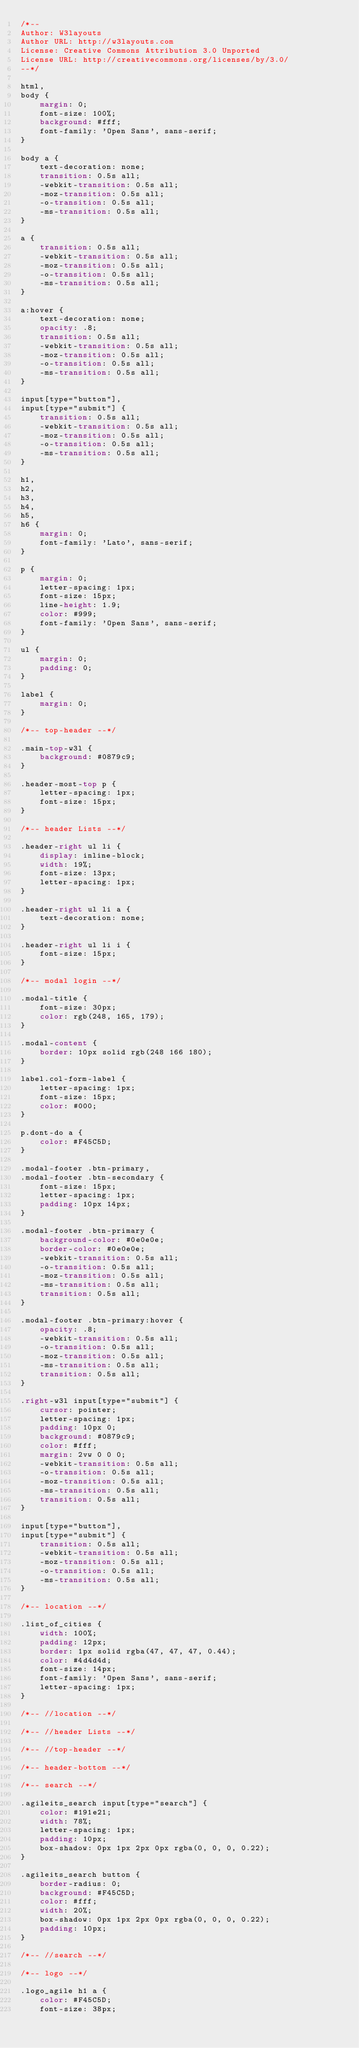Convert code to text. <code><loc_0><loc_0><loc_500><loc_500><_CSS_>/*--
Author: W3layouts
Author URL: http://w3layouts.com
License: Creative Commons Attribution 3.0 Unported
License URL: http://creativecommons.org/licenses/by/3.0/
--*/

html,
body {
    margin: 0;
    font-size: 100%;
    background: #fff;
    font-family: 'Open Sans', sans-serif;
}

body a {
    text-decoration: none;
    transition: 0.5s all;
    -webkit-transition: 0.5s all;
    -moz-transition: 0.5s all;
    -o-transition: 0.5s all;
    -ms-transition: 0.5s all;
}

a {
    transition: 0.5s all;
    -webkit-transition: 0.5s all;
    -moz-transition: 0.5s all;
    -o-transition: 0.5s all;
    -ms-transition: 0.5s all;
}

a:hover {
    text-decoration: none;
    opacity: .8;
    transition: 0.5s all;
    -webkit-transition: 0.5s all;
    -moz-transition: 0.5s all;
    -o-transition: 0.5s all;
    -ms-transition: 0.5s all;
}

input[type="button"],
input[type="submit"] {
    transition: 0.5s all;
    -webkit-transition: 0.5s all;
    -moz-transition: 0.5s all;
    -o-transition: 0.5s all;
    -ms-transition: 0.5s all;
}

h1,
h2,
h3,
h4,
h5,
h6 {
    margin: 0;
    font-family: 'Lato', sans-serif;
}

p {
    margin: 0;
    letter-spacing: 1px;
    font-size: 15px;
    line-height: 1.9;
    color: #999;
    font-family: 'Open Sans', sans-serif;
}

ul {
    margin: 0;
    padding: 0;
}

label {
    margin: 0;
}

/*-- top-header --*/

.main-top-w3l {
    background: #0879c9;
}

.header-most-top p {
    letter-spacing: 1px;
    font-size: 15px;
}

/*-- header Lists --*/

.header-right ul li {
    display: inline-block;
    width: 19%;
    font-size: 13px;
    letter-spacing: 1px;
}

.header-right ul li a {
    text-decoration: none;
}

.header-right ul li i {
    font-size: 15px;
}

/*-- modal login --*/

.modal-title {
    font-size: 30px;
    color: rgb(248, 165, 179);
}

.modal-content {
    border: 10px solid rgb(248 166 180);
}

label.col-form-label {
    letter-spacing: 1px;
    font-size: 15px;
    color: #000;
}

p.dont-do a {
    color: #F45C5D;
}

.modal-footer .btn-primary,
.modal-footer .btn-secondary {
    font-size: 15px;
    letter-spacing: 1px;
    padding: 10px 14px;
}

.modal-footer .btn-primary {
    background-color: #0e0e0e;
    border-color: #0e0e0e;
    -webkit-transition: 0.5s all;
    -o-transition: 0.5s all;
    -moz-transition: 0.5s all;
    -ms-transition: 0.5s all;
    transition: 0.5s all;
}

.modal-footer .btn-primary:hover {
    opacity: .8;
    -webkit-transition: 0.5s all;
    -o-transition: 0.5s all;
    -moz-transition: 0.5s all;
    -ms-transition: 0.5s all;
    transition: 0.5s all;
}

.right-w3l input[type="submit"] {
    cursor: pointer;
    letter-spacing: 1px;
    padding: 10px 0;
    background: #0879c9;
    color: #fff;
    margin: 2vw 0 0 0;
    -webkit-transition: 0.5s all;
    -o-transition: 0.5s all;
    -moz-transition: 0.5s all;
    -ms-transition: 0.5s all;
    transition: 0.5s all;
}

input[type="button"],
input[type="submit"] {
    transition: 0.5s all;
    -webkit-transition: 0.5s all;
    -moz-transition: 0.5s all;
    -o-transition: 0.5s all;
    -ms-transition: 0.5s all;
}

/*-- location --*/

.list_of_cities {
    width: 100%;
    padding: 12px;
    border: 1px solid rgba(47, 47, 47, 0.44);
    color: #4d4d4d;
    font-size: 14px;
    font-family: 'Open Sans', sans-serif;
    letter-spacing: 1px;
}

/*-- //location --*/

/*-- //header Lists --*/

/*-- //top-header --*/

/*-- header-bottom --*/

/*-- search --*/

.agileits_search input[type="search"] {
    color: #191e21;
    width: 78%;
    letter-spacing: 1px;
    padding: 10px;
    box-shadow: 0px 1px 2px 0px rgba(0, 0, 0, 0.22);
}

.agileits_search button {
    border-radius: 0;
    background: #F45C5D;
    color: #fff;
    width: 20%;
    box-shadow: 0px 1px 2px 0px rgba(0, 0, 0, 0.22);
    padding: 10px;
}

/*-- //search --*/

/*-- logo --*/

.logo_agile h1 a {
    color: #F45C5D;
    font-size: 38px;</code> 